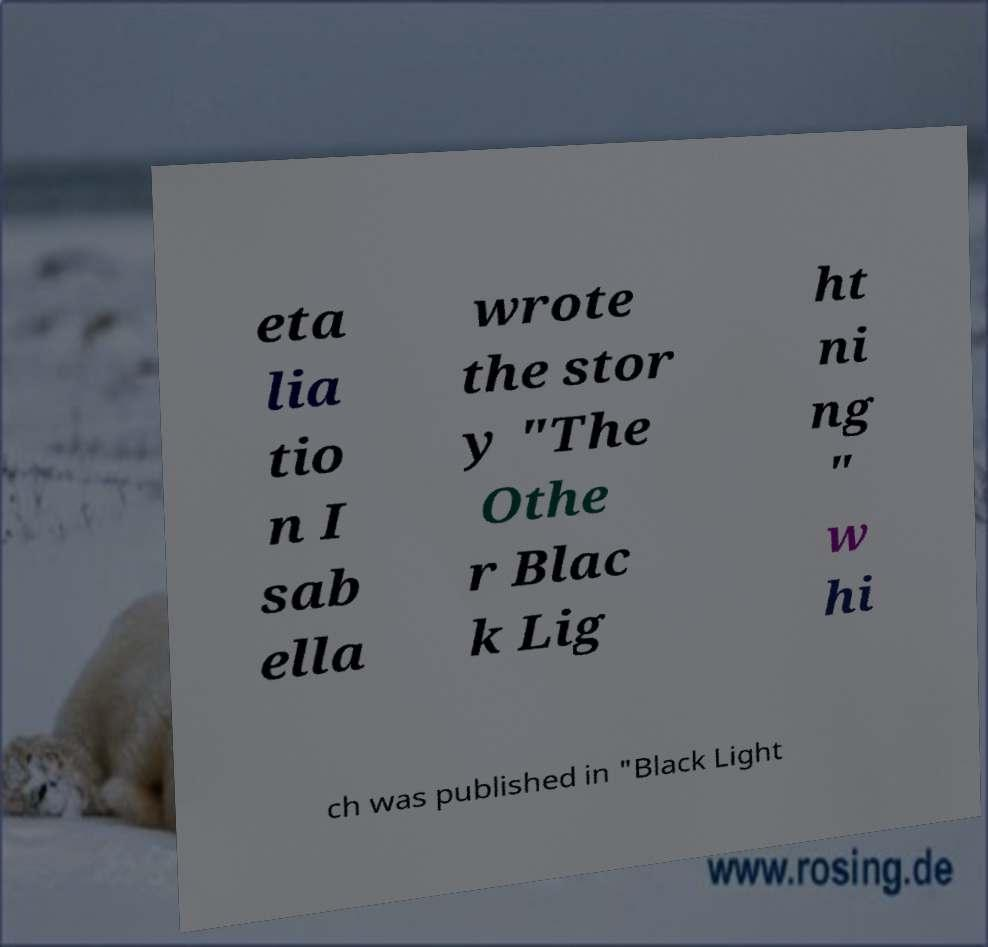Please read and relay the text visible in this image. What does it say? eta lia tio n I sab ella wrote the stor y "The Othe r Blac k Lig ht ni ng " w hi ch was published in "Black Light 